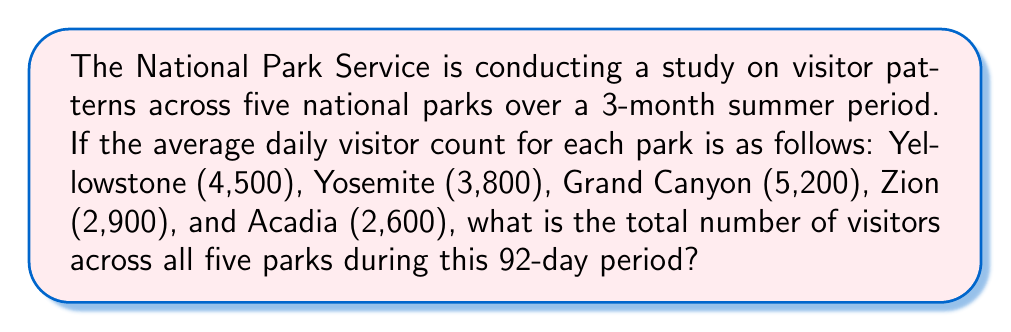Help me with this question. To solve this problem, we'll follow these steps:

1. Calculate the total daily visitors across all five parks:
   $$4,500 + 3,800 + 5,200 + 2,900 + 2,600 = 19,000$$ visitors per day

2. Determine the number of days in the 3-month summer period:
   Given in the question as 92 days

3. Calculate the total number of visitors over the 92-day period:
   $$19,000 \text{ visitors/day} \times 92 \text{ days} = 1,748,000 \text{ visitors}$$

This calculation gives us the total number of visitors across all five national parks during the specified 92-day summer period.
Answer: 1,748,000 visitors 